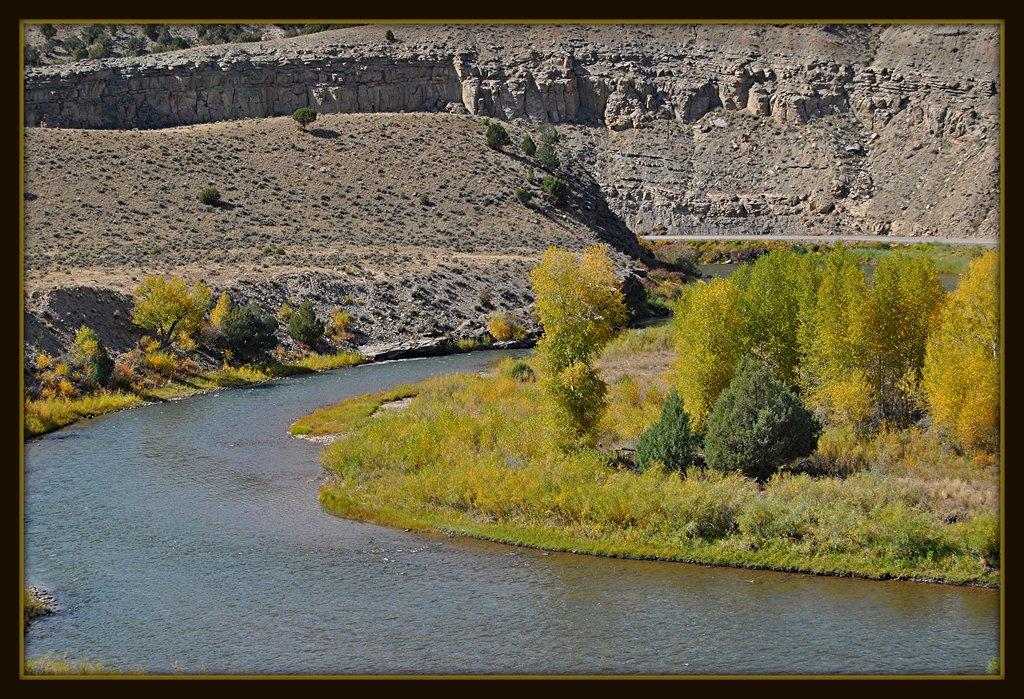What is the setting of the image? The image is in a photo frame. What natural elements can be seen in the image? There is water, plants, sand, and stones visible in the image. What is the level of wealth depicted in the image? There is no indication of wealth in the image, as it features natural elements like water, plants, sand, and stones. 